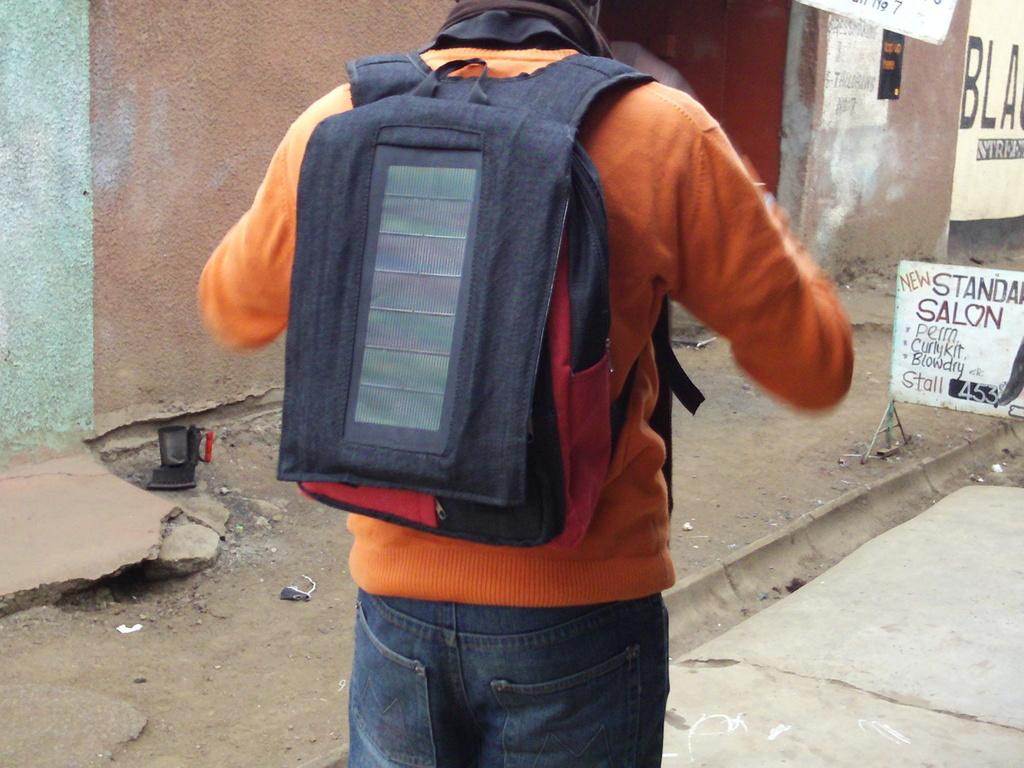<image>
Create a compact narrative representing the image presented. A man wearing a backpack is walking towards a sign for a salon. 